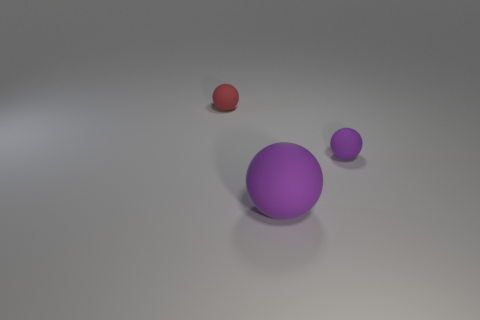There is a red rubber thing; what number of matte spheres are on the right side of it?
Offer a very short reply. 2. How many other rubber things have the same shape as the red rubber object?
Your answer should be very brief. 2. What number of large objects are either blue metallic balls or red rubber things?
Offer a very short reply. 0. Is the color of the tiny matte thing in front of the red matte thing the same as the big object?
Provide a short and direct response. Yes. There is a small rubber ball that is to the right of the small red matte thing; is it the same color as the big ball that is in front of the tiny red sphere?
Ensure brevity in your answer.  Yes. Are there any large purple balls that have the same material as the tiny red object?
Give a very brief answer. Yes. What number of blue objects are either small spheres or large metallic cylinders?
Offer a very short reply. 0. Is the number of large objects that are in front of the red sphere greater than the number of green spheres?
Provide a succinct answer. Yes. What color is the other tiny sphere that is made of the same material as the red sphere?
Give a very brief answer. Purple. There is a small rubber thing that is the same color as the big rubber thing; what shape is it?
Keep it short and to the point. Sphere. 